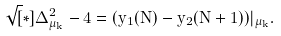<formula> <loc_0><loc_0><loc_500><loc_500>\sqrt { [ } * ] { \Delta ^ { 2 } _ { \mu _ { k } } - 4 } = ( y _ { 1 } ( N ) - y _ { 2 } ( N + 1 ) ) | _ { \mu _ { k } } .</formula> 